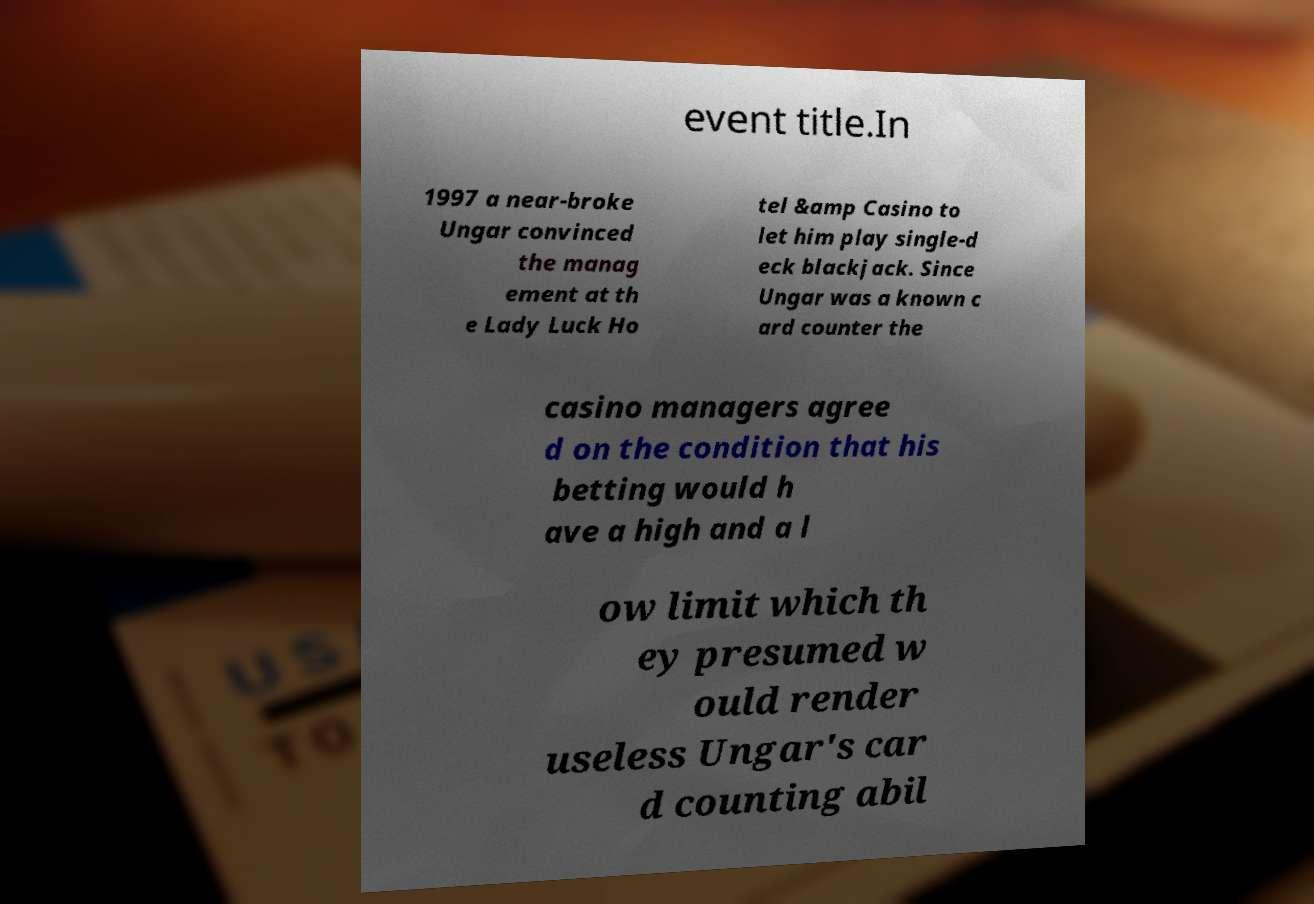Can you accurately transcribe the text from the provided image for me? event title.In 1997 a near-broke Ungar convinced the manag ement at th e Lady Luck Ho tel &amp Casino to let him play single-d eck blackjack. Since Ungar was a known c ard counter the casino managers agree d on the condition that his betting would h ave a high and a l ow limit which th ey presumed w ould render useless Ungar's car d counting abil 